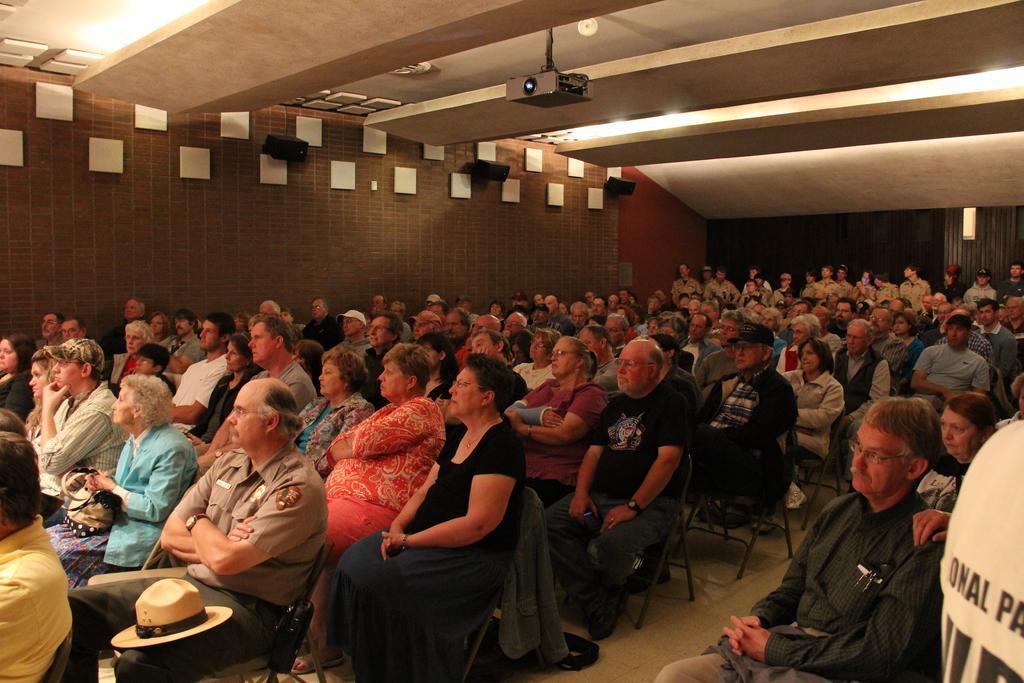Could you give a brief overview of what you see in this image? In this image there are groups of persons sitting on the chair, there is a hat on the person, there are walls, there are speakers, there is a projector, there is a roof, there is a person truncated towards the right of the image, there is a person truncated towards the left of the image. 